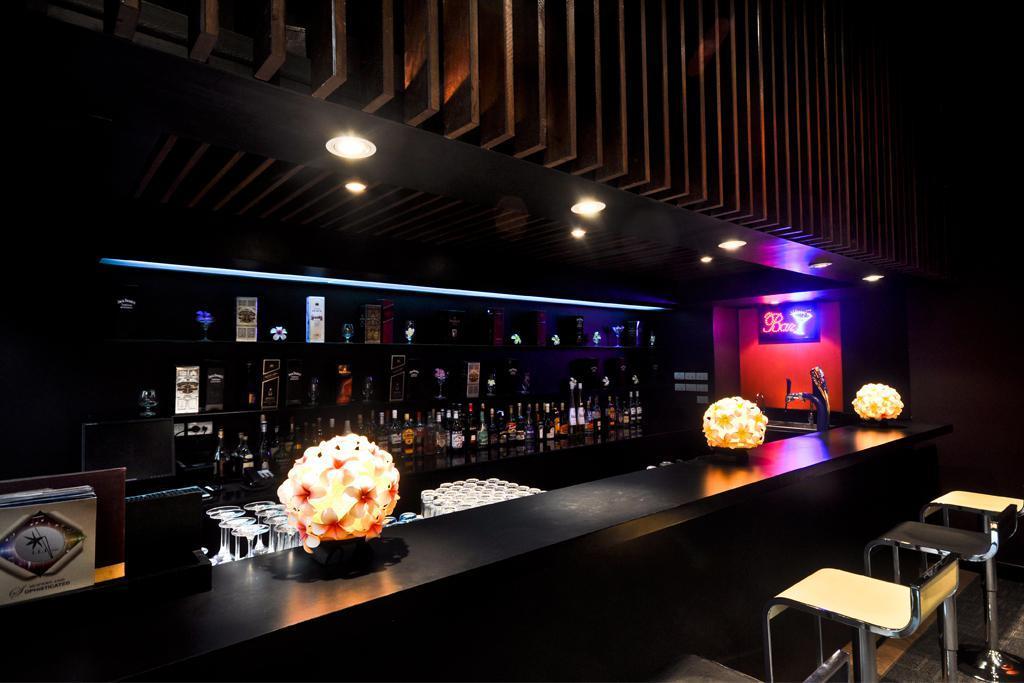Could you give a brief overview of what you see in this image? The image is taken in a bar. In the foreground of the picture there are chairs, desk, flower vase, glasses and other objects. In the center of the picture there are bottles, boxes and other objects. At the top there are lights. In the center of the background there are light and text. 